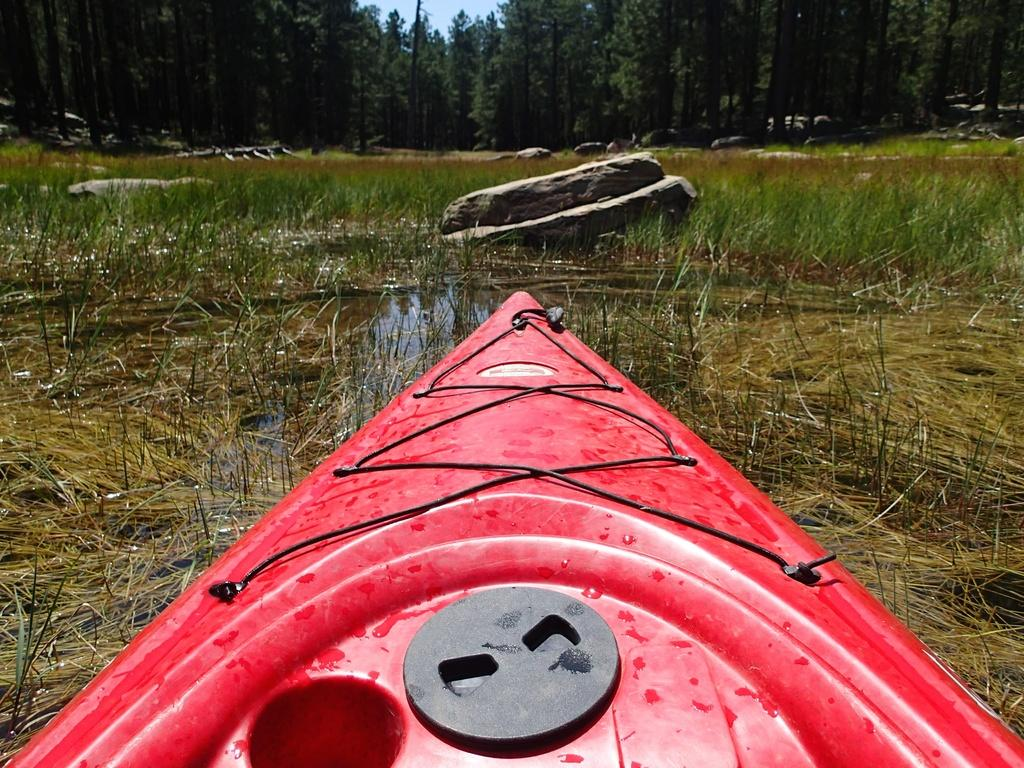What is the main subject of the image? The main subject of the image is a boat. Can you describe the boat in the image? The boat is red in color. What is the setting of the image? The image features water, grass, and stones. What can be seen in the background of the image? There are trees in the background of the image. What type of pest can be seen crawling on the boat in the image? There are no pests visible on the boat in the image. What stage of development is the boat in the image? The image does not provide information about the boat's development stage. 